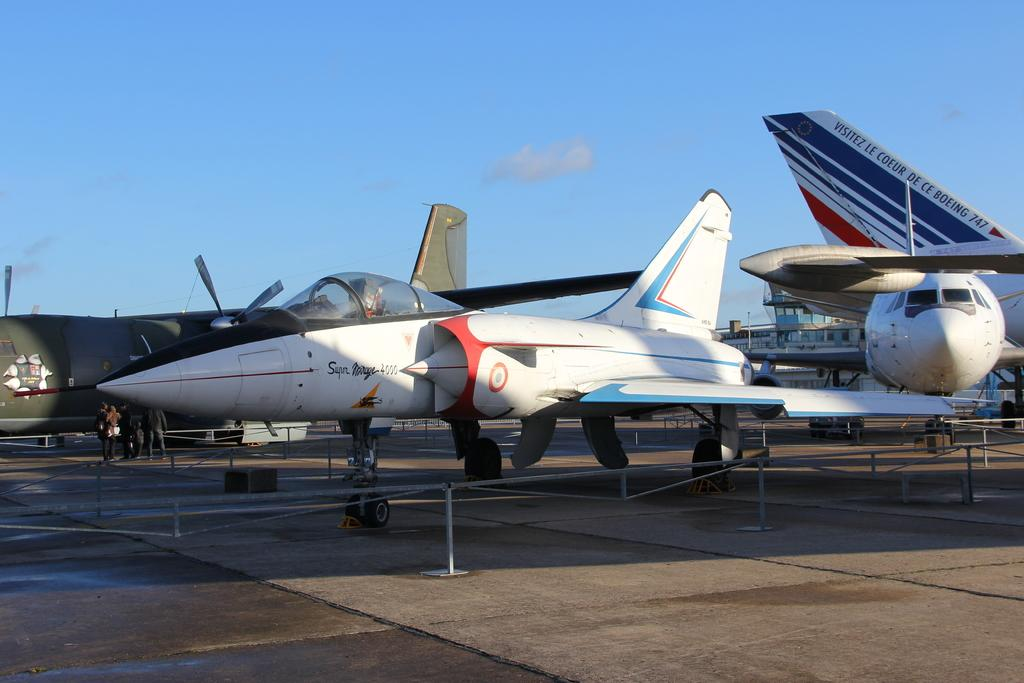<image>
Offer a succinct explanation of the picture presented. the super mirage 4000 plane is sitting with other planes behind a barrier 